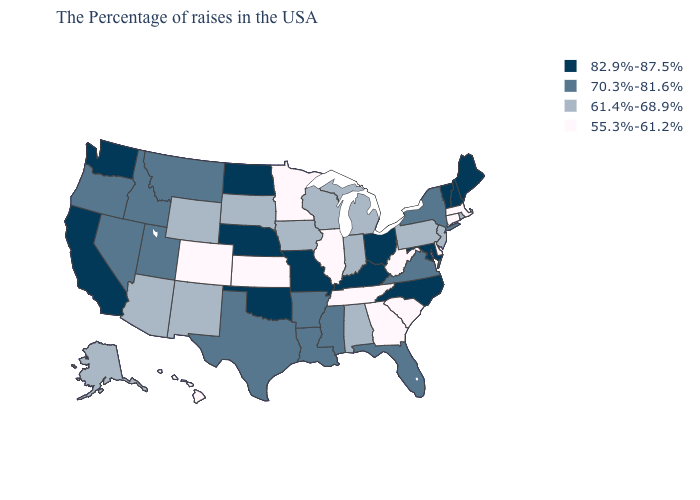What is the value of Mississippi?
Be succinct. 70.3%-81.6%. What is the value of West Virginia?
Be succinct. 55.3%-61.2%. Among the states that border New Mexico , does Oklahoma have the highest value?
Give a very brief answer. Yes. What is the value of Florida?
Keep it brief. 70.3%-81.6%. What is the value of West Virginia?
Write a very short answer. 55.3%-61.2%. Does Iowa have a lower value than Wyoming?
Concise answer only. No. Name the states that have a value in the range 55.3%-61.2%?
Short answer required. Massachusetts, Connecticut, Delaware, South Carolina, West Virginia, Georgia, Tennessee, Illinois, Minnesota, Kansas, Colorado, Hawaii. Among the states that border South Dakota , which have the highest value?
Keep it brief. Nebraska, North Dakota. Does Alaska have a lower value than Indiana?
Give a very brief answer. No. What is the highest value in states that border Iowa?
Be succinct. 82.9%-87.5%. Does the map have missing data?
Quick response, please. No. What is the highest value in states that border West Virginia?
Answer briefly. 82.9%-87.5%. Name the states that have a value in the range 82.9%-87.5%?
Answer briefly. Maine, New Hampshire, Vermont, Maryland, North Carolina, Ohio, Kentucky, Missouri, Nebraska, Oklahoma, North Dakota, California, Washington. What is the highest value in states that border West Virginia?
Write a very short answer. 82.9%-87.5%. What is the value of Hawaii?
Give a very brief answer. 55.3%-61.2%. 